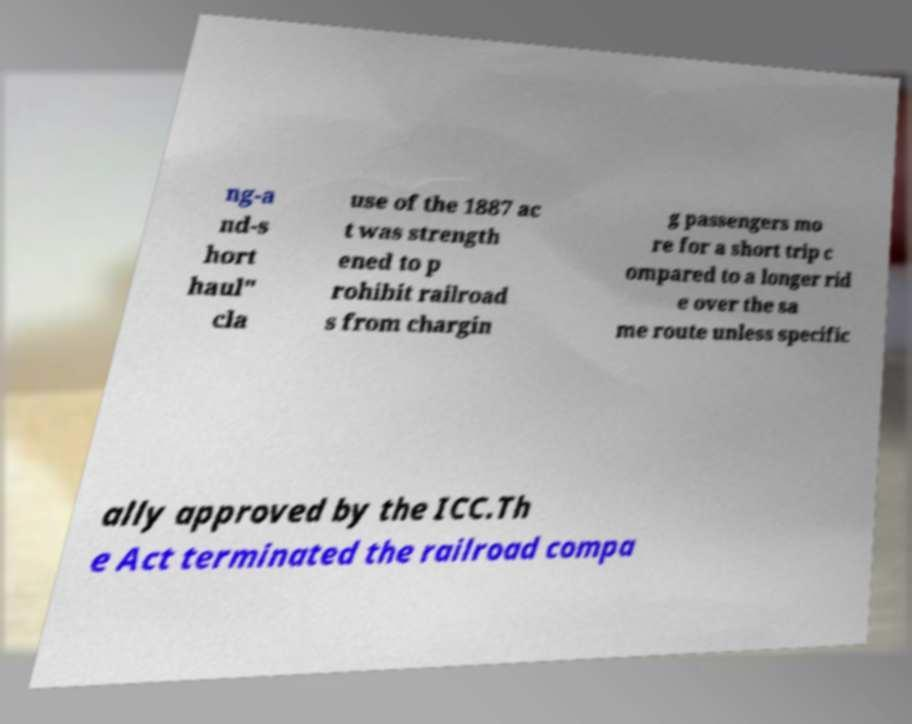There's text embedded in this image that I need extracted. Can you transcribe it verbatim? ng-a nd-s hort haul" cla use of the 1887 ac t was strength ened to p rohibit railroad s from chargin g passengers mo re for a short trip c ompared to a longer rid e over the sa me route unless specific ally approved by the ICC.Th e Act terminated the railroad compa 